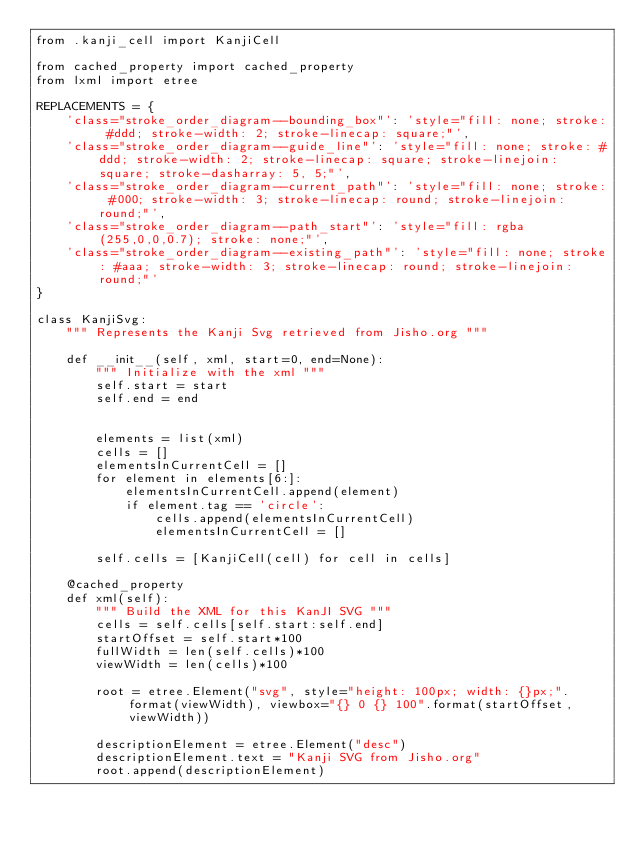<code> <loc_0><loc_0><loc_500><loc_500><_Python_>from .kanji_cell import KanjiCell

from cached_property import cached_property
from lxml import etree

REPLACEMENTS = {
    'class="stroke_order_diagram--bounding_box"': 'style="fill: none; stroke: #ddd; stroke-width: 2; stroke-linecap: square;"',
    'class="stroke_order_diagram--guide_line"': 'style="fill: none; stroke: #ddd; stroke-width: 2; stroke-linecap: square; stroke-linejoin: square; stroke-dasharray: 5, 5;"',
    'class="stroke_order_diagram--current_path"': 'style="fill: none; stroke: #000; stroke-width: 3; stroke-linecap: round; stroke-linejoin: round;"',
    'class="stroke_order_diagram--path_start"': 'style="fill: rgba(255,0,0,0.7); stroke: none;"',
    'class="stroke_order_diagram--existing_path"': 'style="fill: none; stroke: #aaa; stroke-width: 3; stroke-linecap: round; stroke-linejoin: round;"'
}

class KanjiSvg:
    """ Represents the Kanji Svg retrieved from Jisho.org """

    def __init__(self, xml, start=0, end=None):
        """ Initialize with the xml """
        self.start = start
        self.end = end


        elements = list(xml)
        cells = []
        elementsInCurrentCell = []
        for element in elements[6:]:
            elementsInCurrentCell.append(element)
            if element.tag == 'circle':
                cells.append(elementsInCurrentCell)
                elementsInCurrentCell = []

        self.cells = [KanjiCell(cell) for cell in cells]

    @cached_property
    def xml(self):
        """ Build the XML for this KanJI SVG """
        cells = self.cells[self.start:self.end]
        startOffset = self.start*100
        fullWidth = len(self.cells)*100
        viewWidth = len(cells)*100

        root = etree.Element("svg", style="height: 100px; width: {}px;".format(viewWidth), viewbox="{} 0 {} 100".format(startOffset, viewWidth))
        
        descriptionElement = etree.Element("desc")
        descriptionElement.text = "Kanji SVG from Jisho.org"
        root.append(descriptionElement)
</code> 